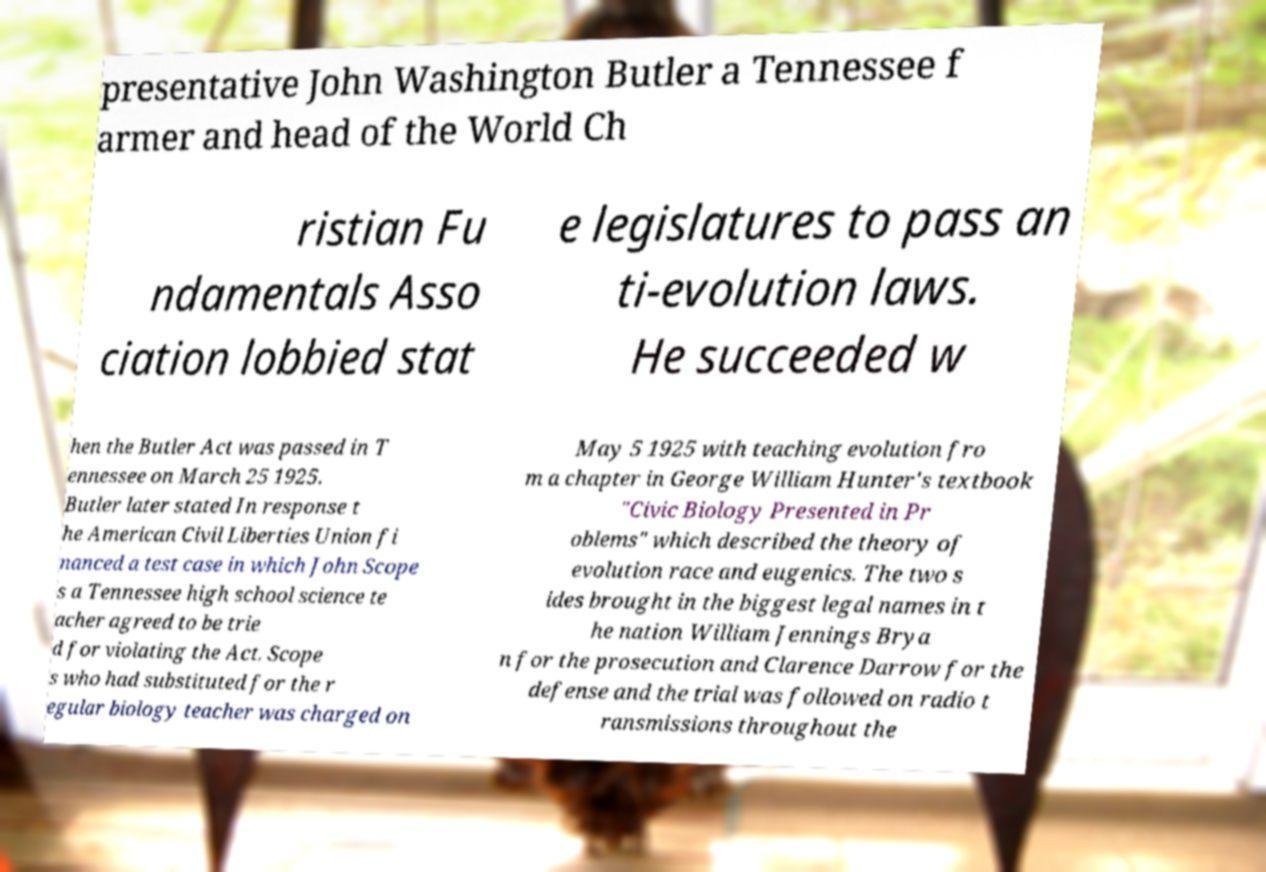For documentation purposes, I need the text within this image transcribed. Could you provide that? presentative John Washington Butler a Tennessee f armer and head of the World Ch ristian Fu ndamentals Asso ciation lobbied stat e legislatures to pass an ti-evolution laws. He succeeded w hen the Butler Act was passed in T ennessee on March 25 1925. Butler later stated In response t he American Civil Liberties Union fi nanced a test case in which John Scope s a Tennessee high school science te acher agreed to be trie d for violating the Act. Scope s who had substituted for the r egular biology teacher was charged on May 5 1925 with teaching evolution fro m a chapter in George William Hunter's textbook "Civic Biology Presented in Pr oblems" which described the theory of evolution race and eugenics. The two s ides brought in the biggest legal names in t he nation William Jennings Brya n for the prosecution and Clarence Darrow for the defense and the trial was followed on radio t ransmissions throughout the 